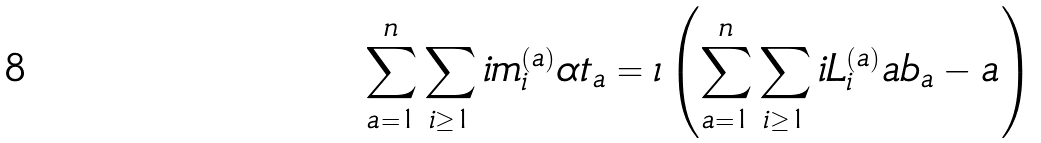<formula> <loc_0><loc_0><loc_500><loc_500>\sum _ { a = 1 } ^ { n } \sum _ { i \geq 1 } i m _ { i } ^ { ( a ) } \alpha t _ { a } = \iota \left ( \sum _ { a = 1 } ^ { n } \sum _ { i \geq 1 } i L _ { i } ^ { ( a ) } \L a b _ { a } - \L a \right )</formula> 